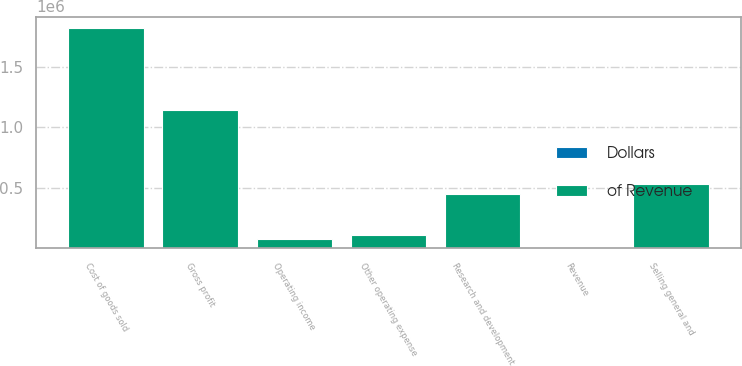Convert chart. <chart><loc_0><loc_0><loc_500><loc_500><stacked_bar_chart><ecel><fcel>Revenue<fcel>Cost of goods sold<fcel>Gross profit<fcel>Research and development<fcel>Selling general and<fcel>Other operating expense<fcel>Operating income<nl><fcel>of Revenue<fcel>100<fcel>1.82657e+06<fcel>1.14697e+06<fcel>445103<fcel>527751<fcel>103830<fcel>70282<nl><fcel>Dollars<fcel>100<fcel>61.4<fcel>38.6<fcel>15<fcel>17.7<fcel>3.5<fcel>2.4<nl></chart> 